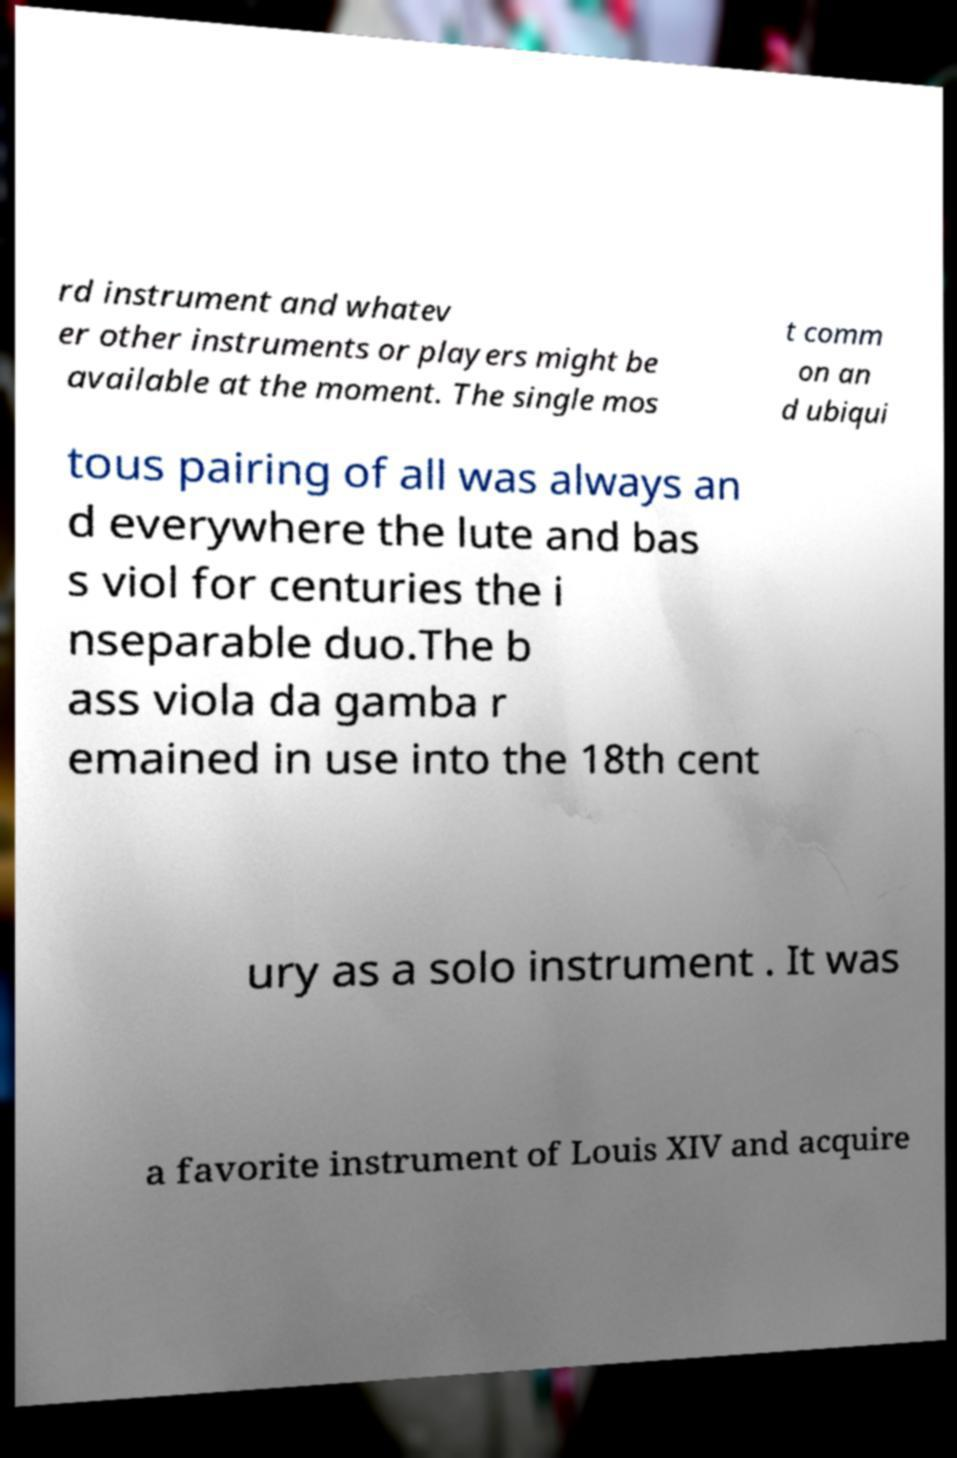Can you read and provide the text displayed in the image?This photo seems to have some interesting text. Can you extract and type it out for me? rd instrument and whatev er other instruments or players might be available at the moment. The single mos t comm on an d ubiqui tous pairing of all was always an d everywhere the lute and bas s viol for centuries the i nseparable duo.The b ass viola da gamba r emained in use into the 18th cent ury as a solo instrument . It was a favorite instrument of Louis XIV and acquire 